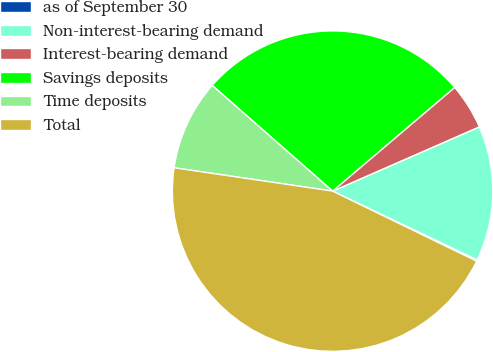<chart> <loc_0><loc_0><loc_500><loc_500><pie_chart><fcel>as of September 30<fcel>Non-interest-bearing demand<fcel>Interest-bearing demand<fcel>Savings deposits<fcel>Time deposits<fcel>Total<nl><fcel>0.14%<fcel>13.64%<fcel>4.64%<fcel>27.33%<fcel>9.14%<fcel>45.13%<nl></chart> 